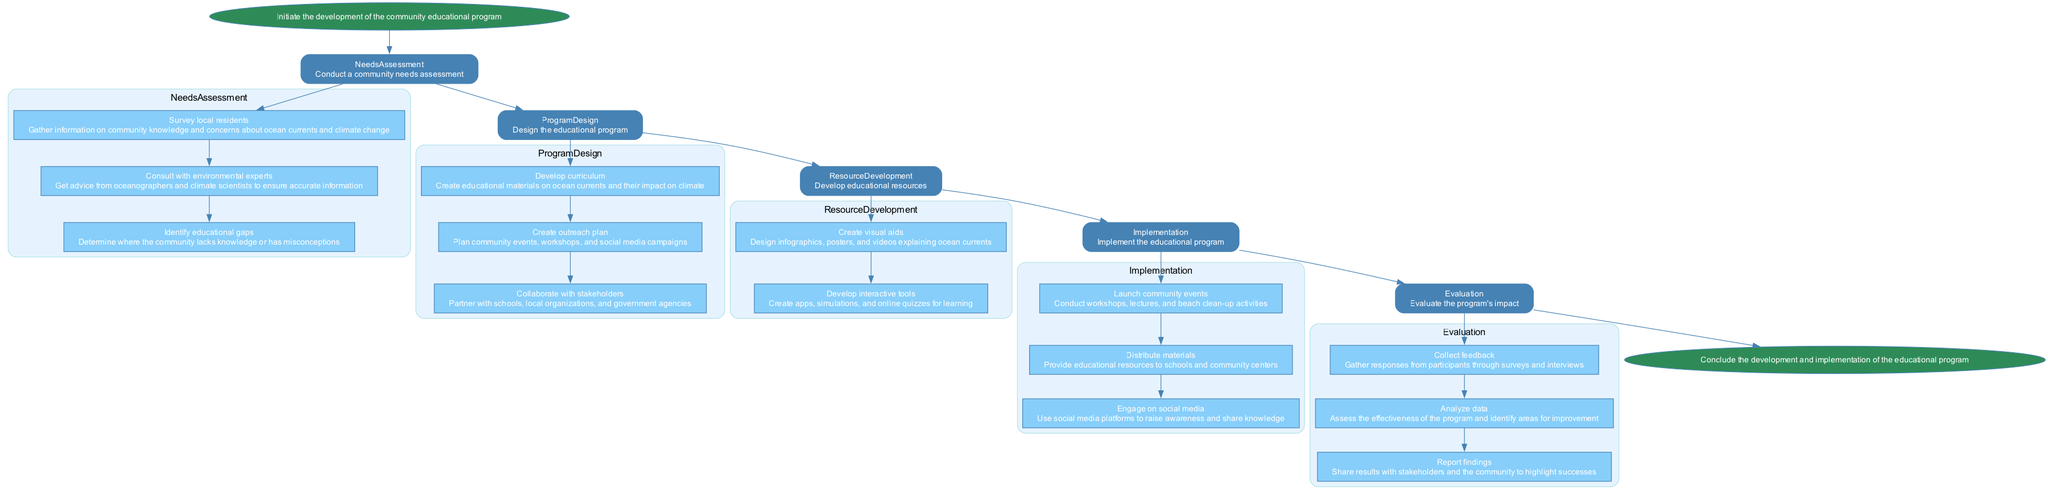What is the first step in the program's development? The first step is "Initiate the development of the community educational program," which is represented at the top of the diagram.
Answer: Initiate the development of the community educational program How many steps are in the "Needs Assessment" phase? The "Needs Assessment" phase has three specific tasks: surveying local residents, consulting with environmental experts, and identifying educational gaps. This is counted from the list included under that phase in the diagram.
Answer: 3 What are the educational resources developed in the "Resource Development" step? The "Resource Development" step includes two tasks: creating visual aids and developing interactive tools, both aimed at enhancing community education on ocean currents.
Answer: Create visual aids, Develop interactive tools What is the last action in the "Implementation" phase? The last action in the "Implementation" phase is "Engage on social media," which serves as a critical outreach tool after community events and material distribution.
Answer: Engage on social media Which phase directly follows "Program Design"? The phase that directly follows "Program Design" is "Resource Development," indicating that once the program design is completed, the next step is to gather resources for implementation.
Answer: Resource Development How many nodes are there in total in the flowchart? By counting all main nodes including steps and phases, the total comes to six nodes: Start, Needs Assessment, Program Design, Resource Development, Implementation, Evaluation, and End, leading to a complete progression through the flowchart.
Answer: 7 What type of collaboration is emphasized in the "Program Design" phase? The "Program Design" phase emphasizes collaboration with stakeholders, highlighting the importance of engaging local organizations and government agencies for effective program development.
Answer: Collaborate with stakeholders What method is used to evaluate the program's impact? The method used to evaluate the program's impact involves collecting feedback from participants, which is crucial for understanding the program's effectiveness.
Answer: Collect feedback Which task involves the community's active participation? The task that involves the community's active participation is "Launch community events," as it requires residents to engage in workshops and clean-up activities, fostering collaborative learning.
Answer: Launch community events 